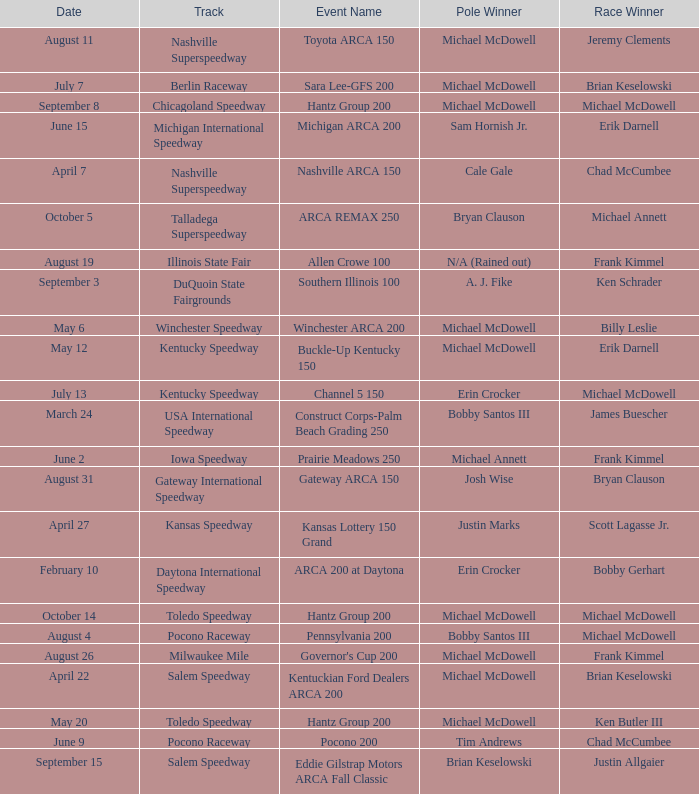Tell me the track for june 9 Pocono Raceway. 